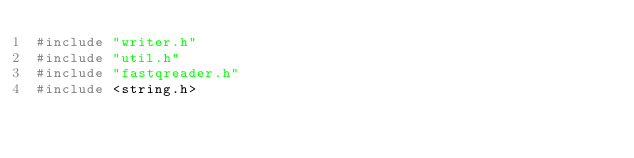Convert code to text. <code><loc_0><loc_0><loc_500><loc_500><_C++_>#include "writer.h"
#include "util.h"
#include "fastqreader.h"
#include <string.h>
</code> 